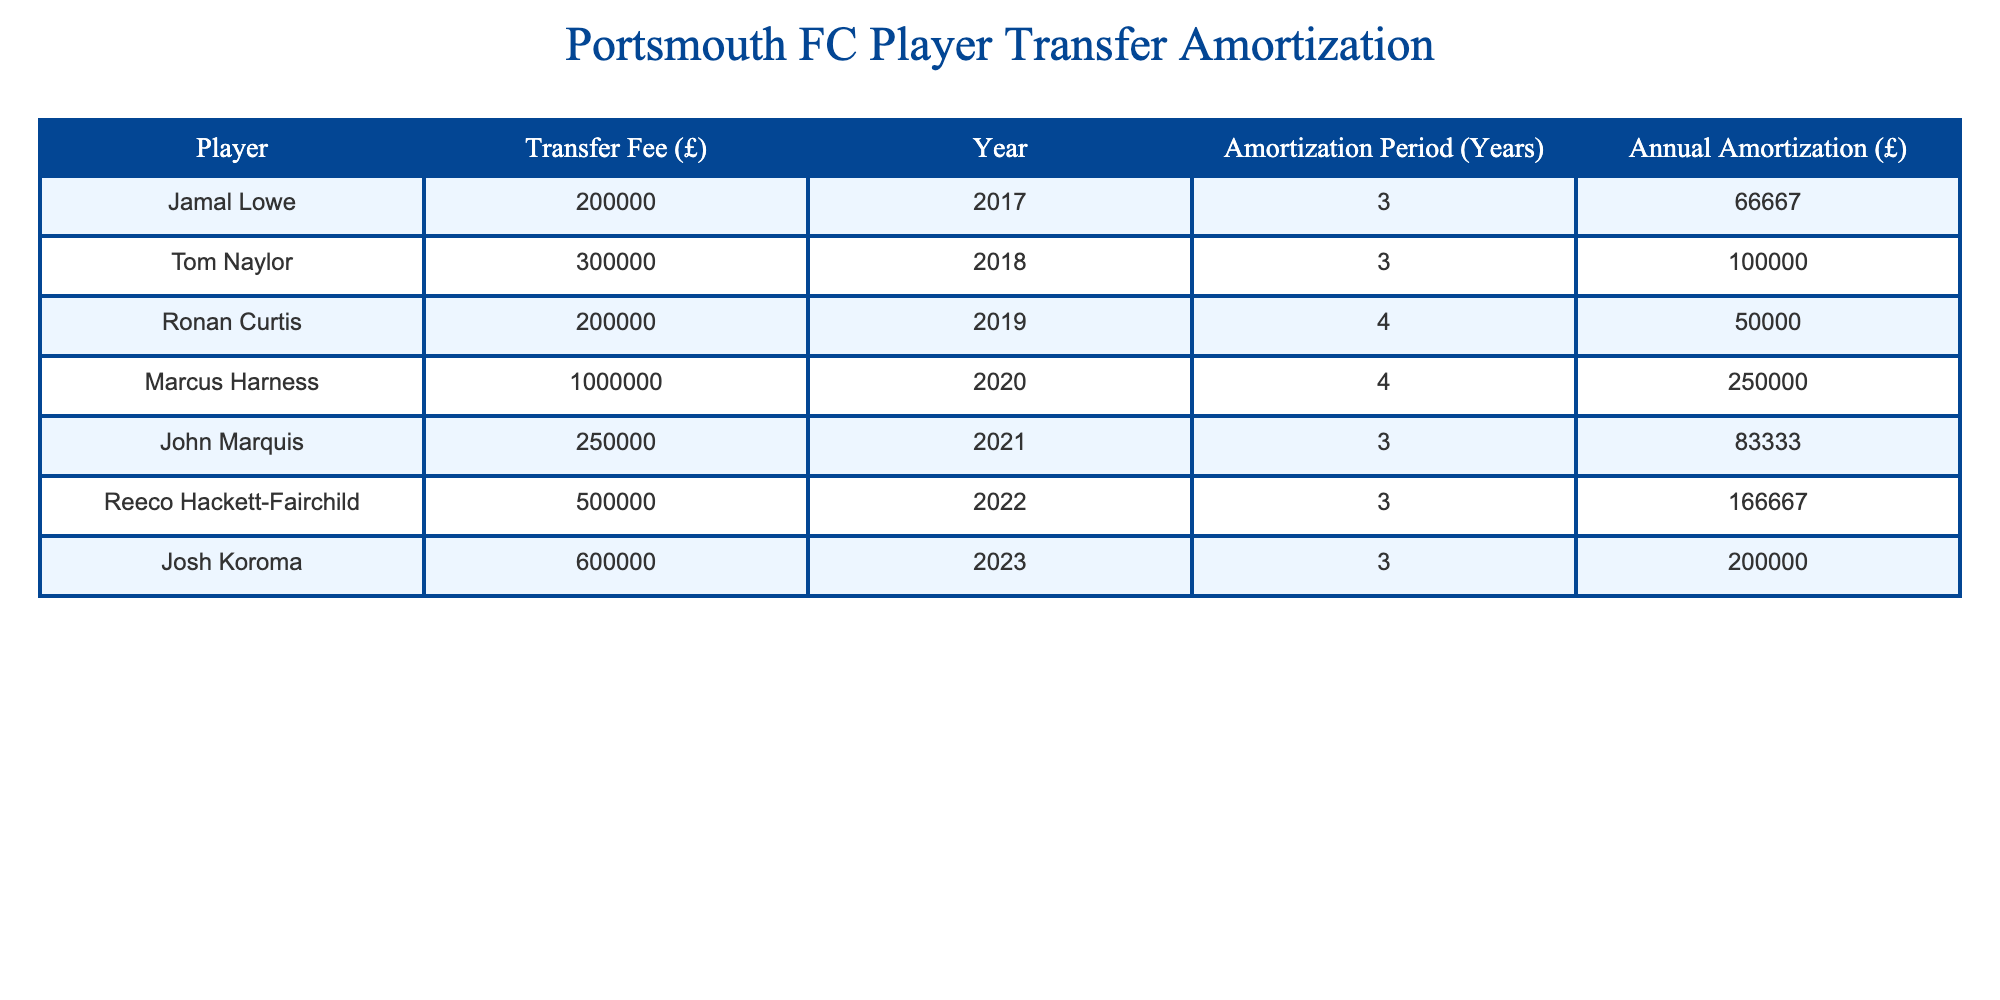What is the transfer fee for Marcus Harness? The table lists the transfer fee for Marcus Harness as 1,000,000 pounds. This value can be found in the "Transfer Fee (£)" column associated with the row for Marcus Harness.
Answer: 1,000,000 How many players have an amortization period of 3 years? The table shows that there are four players with an amortization period of 3 years: Jamal Lowe, Tom Naylor, John Marquis, and Reeco Hackett-Fairchild. This is determined by counting the number of occurrences of "3" in the "Amortization Period (Years)" column.
Answer: 4 What is the total annual amortization for all players in the table? To find the total annual amortization, you sum the values in the "Annual Amortization (£)" column: 66,667 + 100,000 + 50,000 + 250,000 + 83,333 + 166,667 + 200,000 = 416,667.
Answer: 416,667 Is the transfer fee for Reeco Hackett-Fairchild greater than that for John Marquis? The transfer fee for Reeco Hackett-Fairchild is 500,000 pounds, while the fee for John Marquis is 250,000 pounds. Since 500,000 is greater than 250,000, the answer is yes.
Answer: Yes What is the average transfer fee paid by Portsmouth FC over the past decade? First, sum all the transfer fees: 200,000 + 300,000 + 200,000 + 1,000,000 + 250,000 + 500,000 + 600,000 = 3,050,000. There are 7 players, so the average is calculated as 3,050,000 / 7 = 435,714.29. Therefore, the average transfer fee is approximately 435,714.29 pounds.
Answer: 435,714.29 